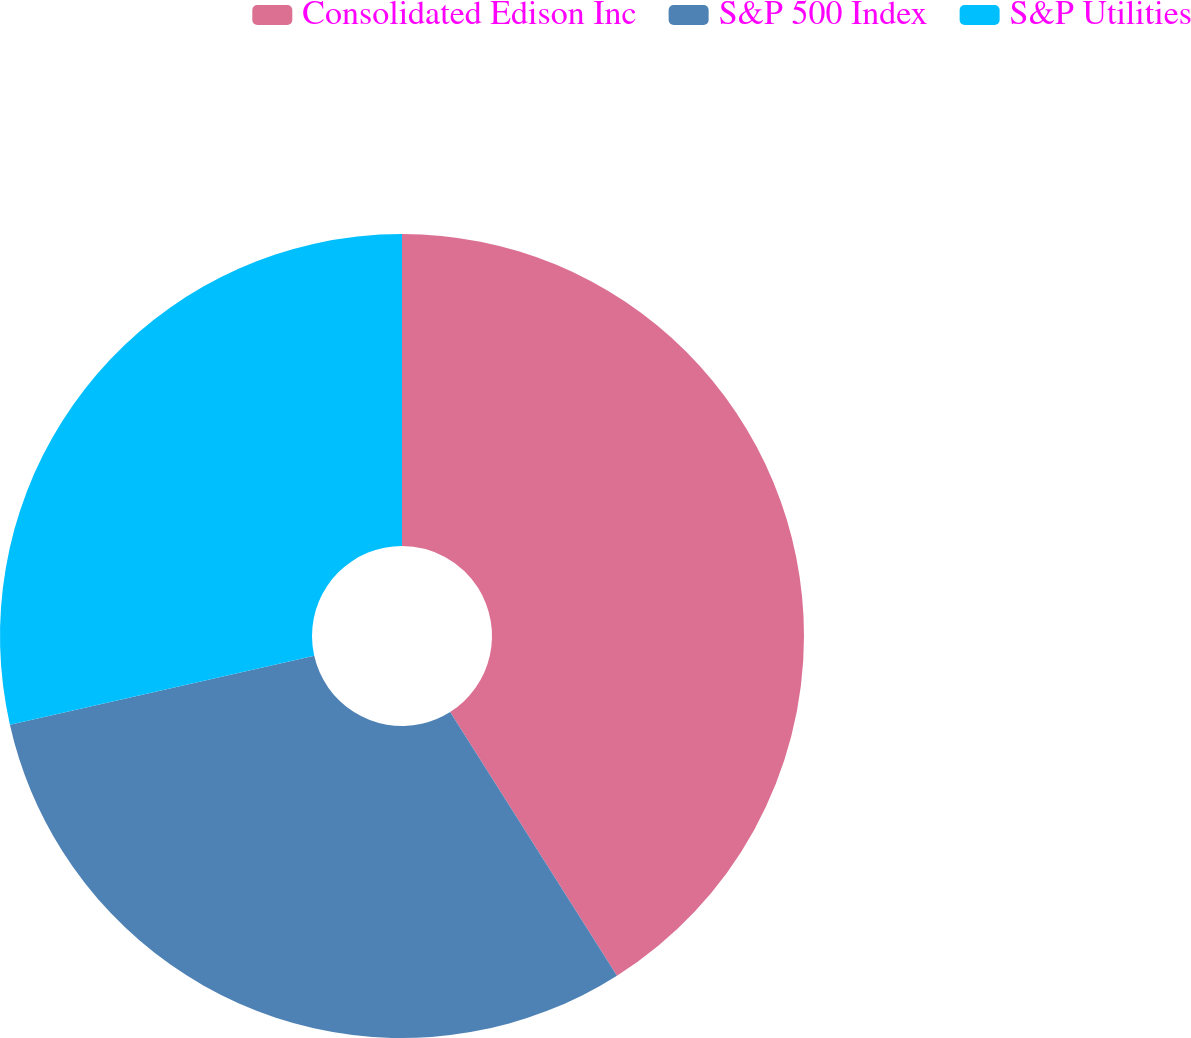Convert chart. <chart><loc_0><loc_0><loc_500><loc_500><pie_chart><fcel>Consolidated Edison Inc<fcel>S&P 500 Index<fcel>S&P Utilities<nl><fcel>41.02%<fcel>30.44%<fcel>28.54%<nl></chart> 